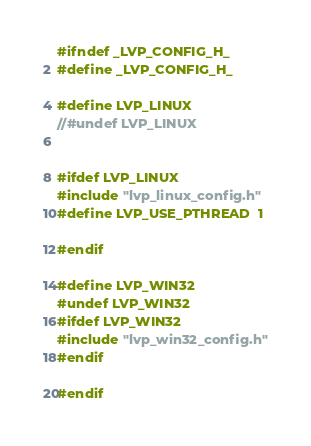<code> <loc_0><loc_0><loc_500><loc_500><_C_>#ifndef _LVP_CONFIG_H_
#define _LVP_CONFIG_H_

#define LVP_LINUX
//#undef LVP_LINUX


#ifdef LVP_LINUX
#include "lvp_linux_config.h"
#define LVP_USE_PTHREAD  1

#endif

#define LVP_WIN32 
#undef LVP_WIN32
#ifdef LVP_WIN32
#include "lvp_win32_config.h"
#endif

#endif</code> 